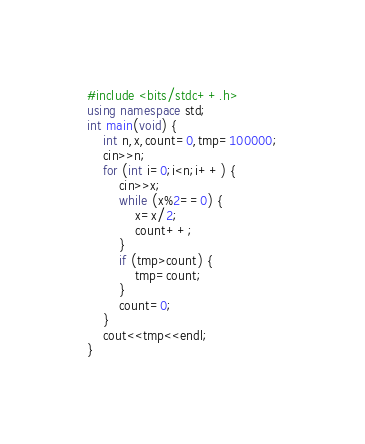<code> <loc_0><loc_0><loc_500><loc_500><_C++_>#include <bits/stdc++.h>
using namespace std;
int main(void) {
    int n,x,count=0,tmp=100000;
    cin>>n;
    for (int i=0;i<n;i++) {
        cin>>x;
        while (x%2==0) {
            x=x/2;
            count++;
        }
        if (tmp>count) {
            tmp=count;
        }
        count=0;
    }
    cout<<tmp<<endl;
}
</code> 